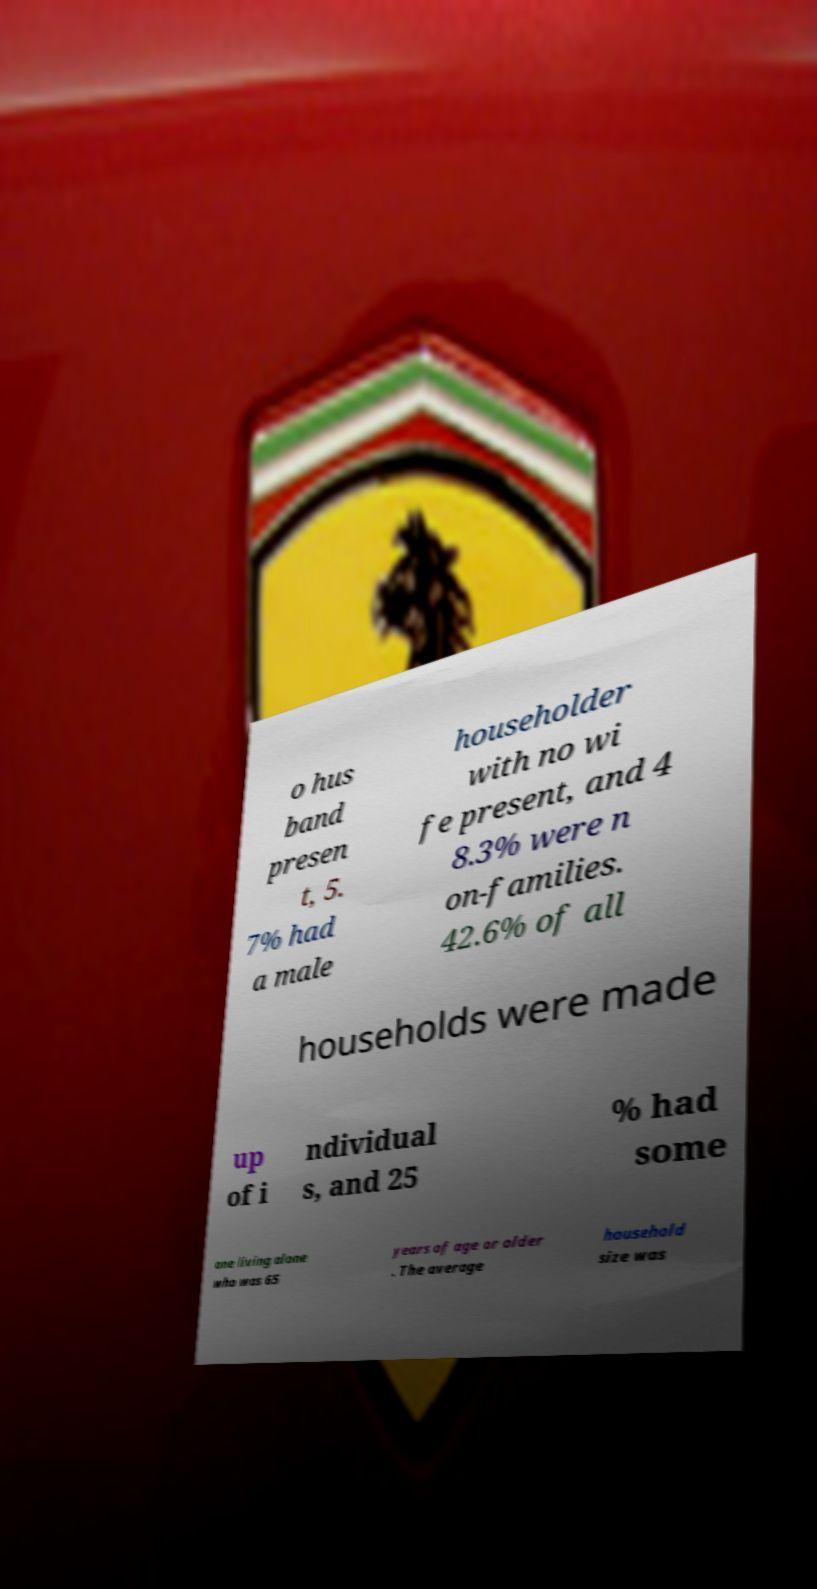Can you read and provide the text displayed in the image?This photo seems to have some interesting text. Can you extract and type it out for me? o hus band presen t, 5. 7% had a male householder with no wi fe present, and 4 8.3% were n on-families. 42.6% of all households were made up of i ndividual s, and 25 % had some one living alone who was 65 years of age or older . The average household size was 